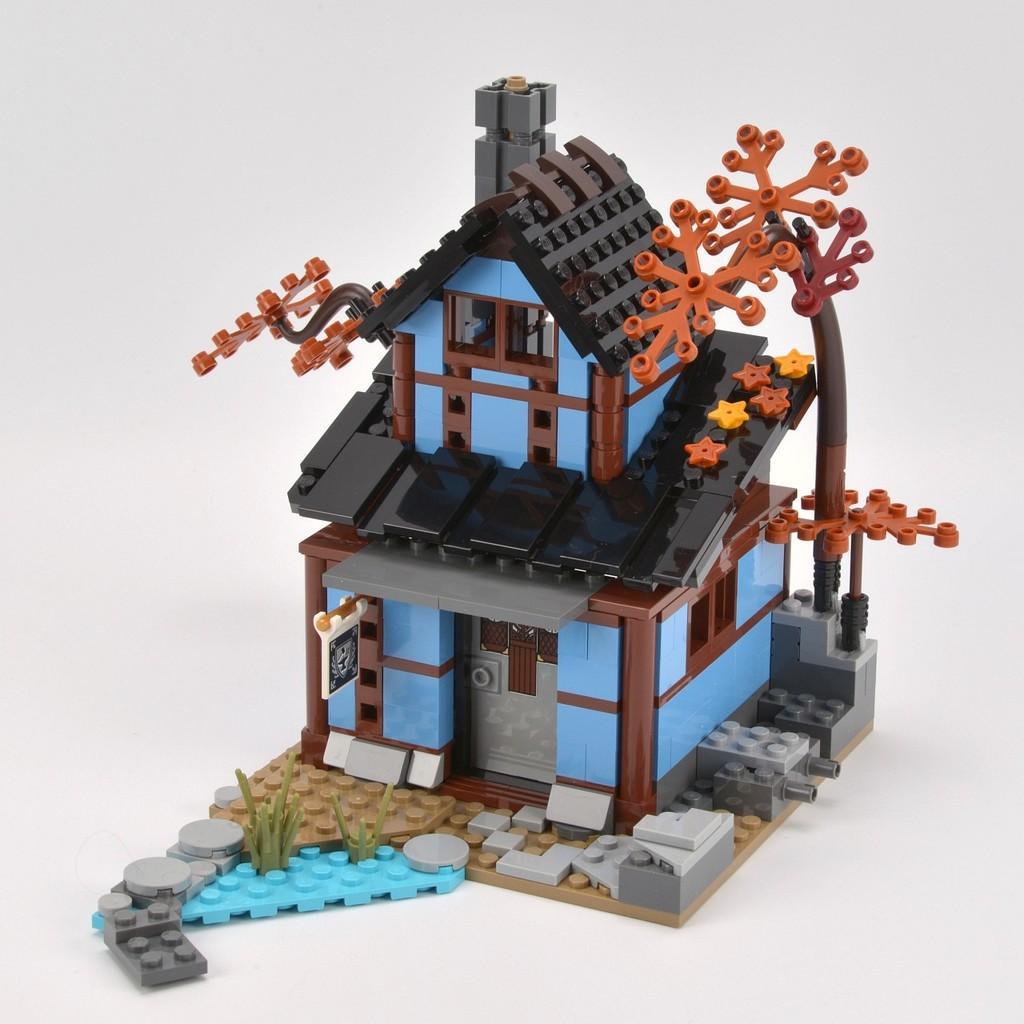Describe this image in one or two sentences. In this image I can see the miniature of the house. It is in black, blue, brown and ash color. It is on the white color surface. 